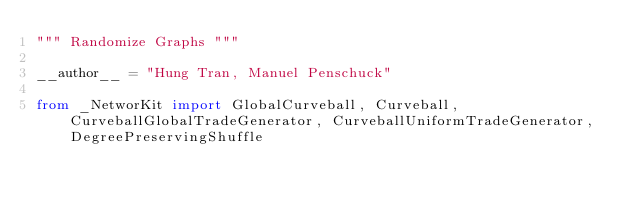<code> <loc_0><loc_0><loc_500><loc_500><_Python_>""" Randomize Graphs """

__author__ = "Hung Tran, Manuel Penschuck"

from _NetworKit import GlobalCurveball, Curveball, CurveballGlobalTradeGenerator, CurveballUniformTradeGenerator, DegreePreservingShuffle
</code> 